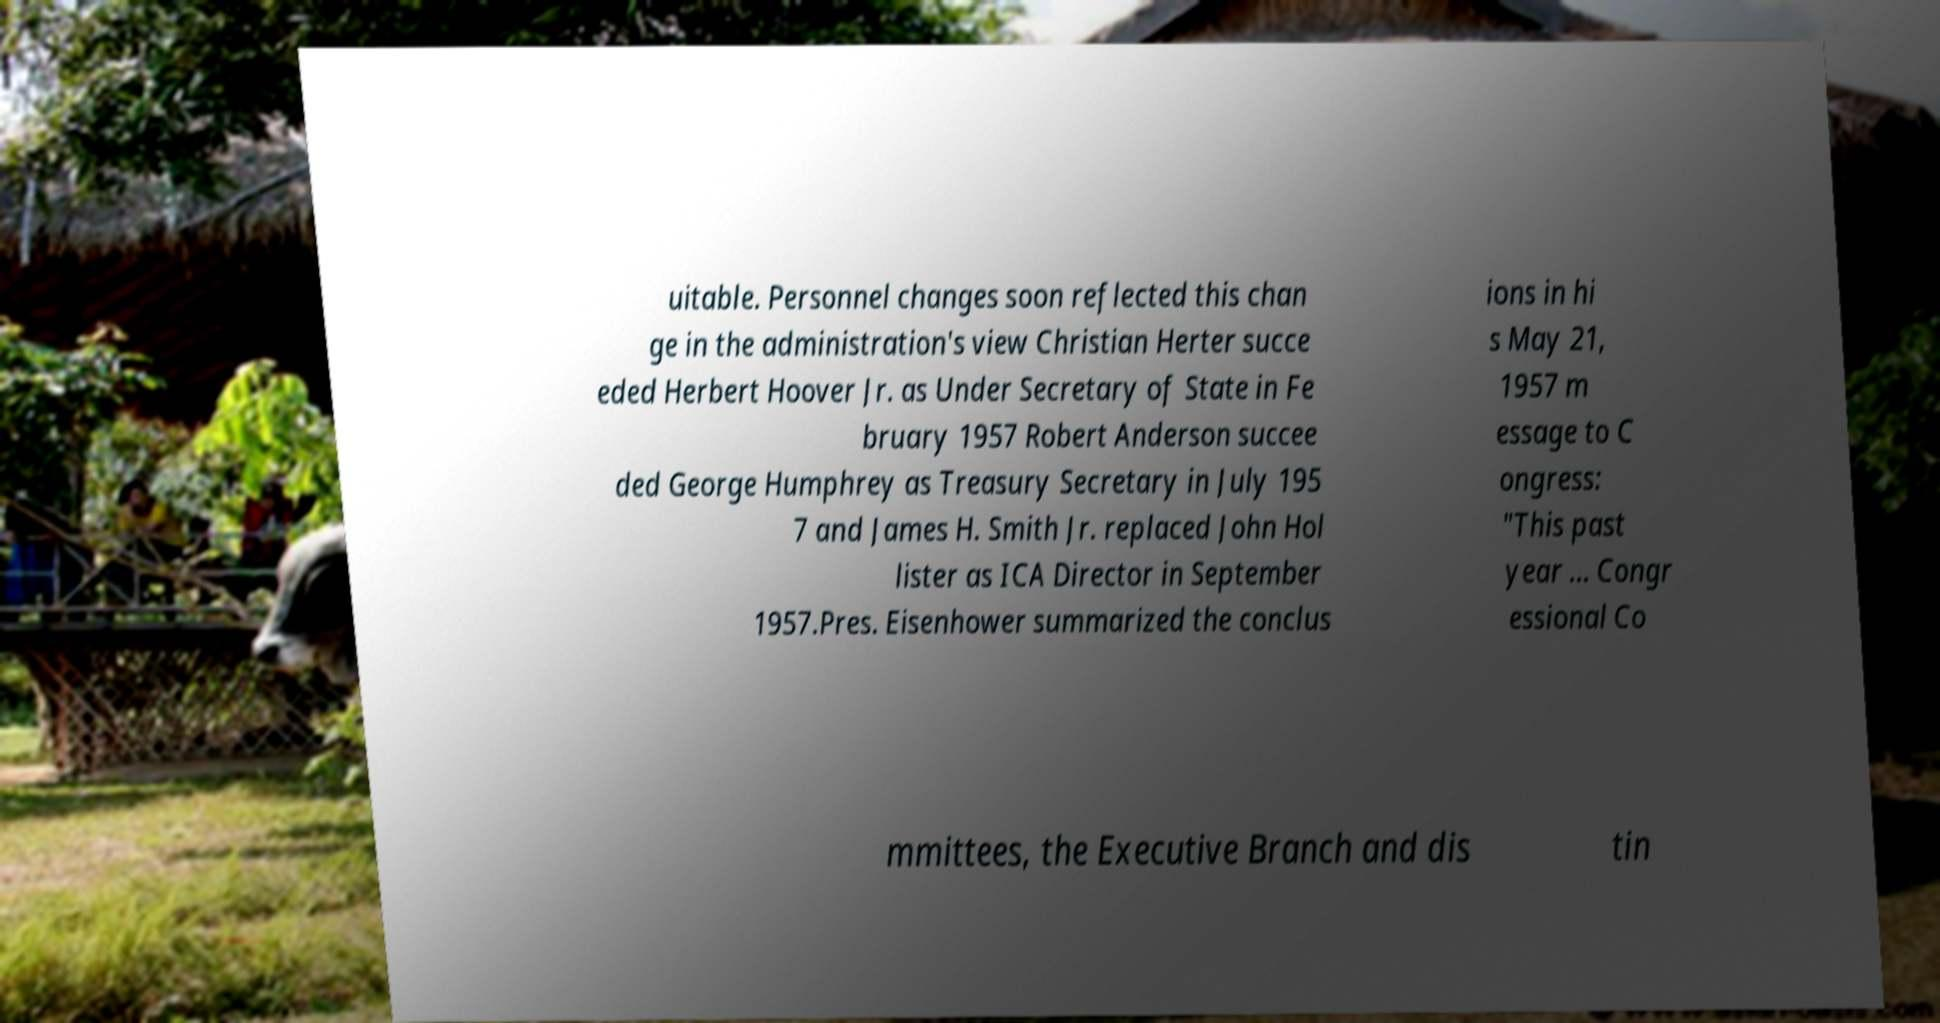Please identify and transcribe the text found in this image. uitable. Personnel changes soon reflected this chan ge in the administration's view Christian Herter succe eded Herbert Hoover Jr. as Under Secretary of State in Fe bruary 1957 Robert Anderson succee ded George Humphrey as Treasury Secretary in July 195 7 and James H. Smith Jr. replaced John Hol lister as ICA Director in September 1957.Pres. Eisenhower summarized the conclus ions in hi s May 21, 1957 m essage to C ongress: "This past year ... Congr essional Co mmittees, the Executive Branch and dis tin 